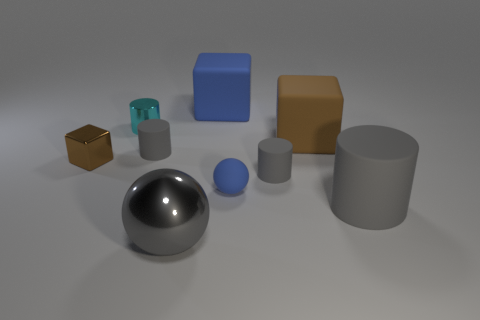Is there a object of the same color as the small block? yes 